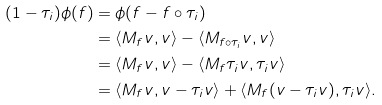Convert formula to latex. <formula><loc_0><loc_0><loc_500><loc_500>( 1 - \tau _ { i } ) \phi ( f ) & = \phi ( f - f \circ \tau _ { i } ) \\ & = \langle M _ { f } v , v \rangle - \langle M _ { f \circ \tau _ { i } } v , v \rangle \\ & = \langle M _ { f } v , v \rangle - \langle M _ { f } \tau _ { i } v , \tau _ { i } v \rangle \\ & = \langle M _ { f } v , v - \tau _ { i } v \rangle + \langle M _ { f } ( v - \tau _ { i } v ) , \tau _ { i } v \rangle .</formula> 